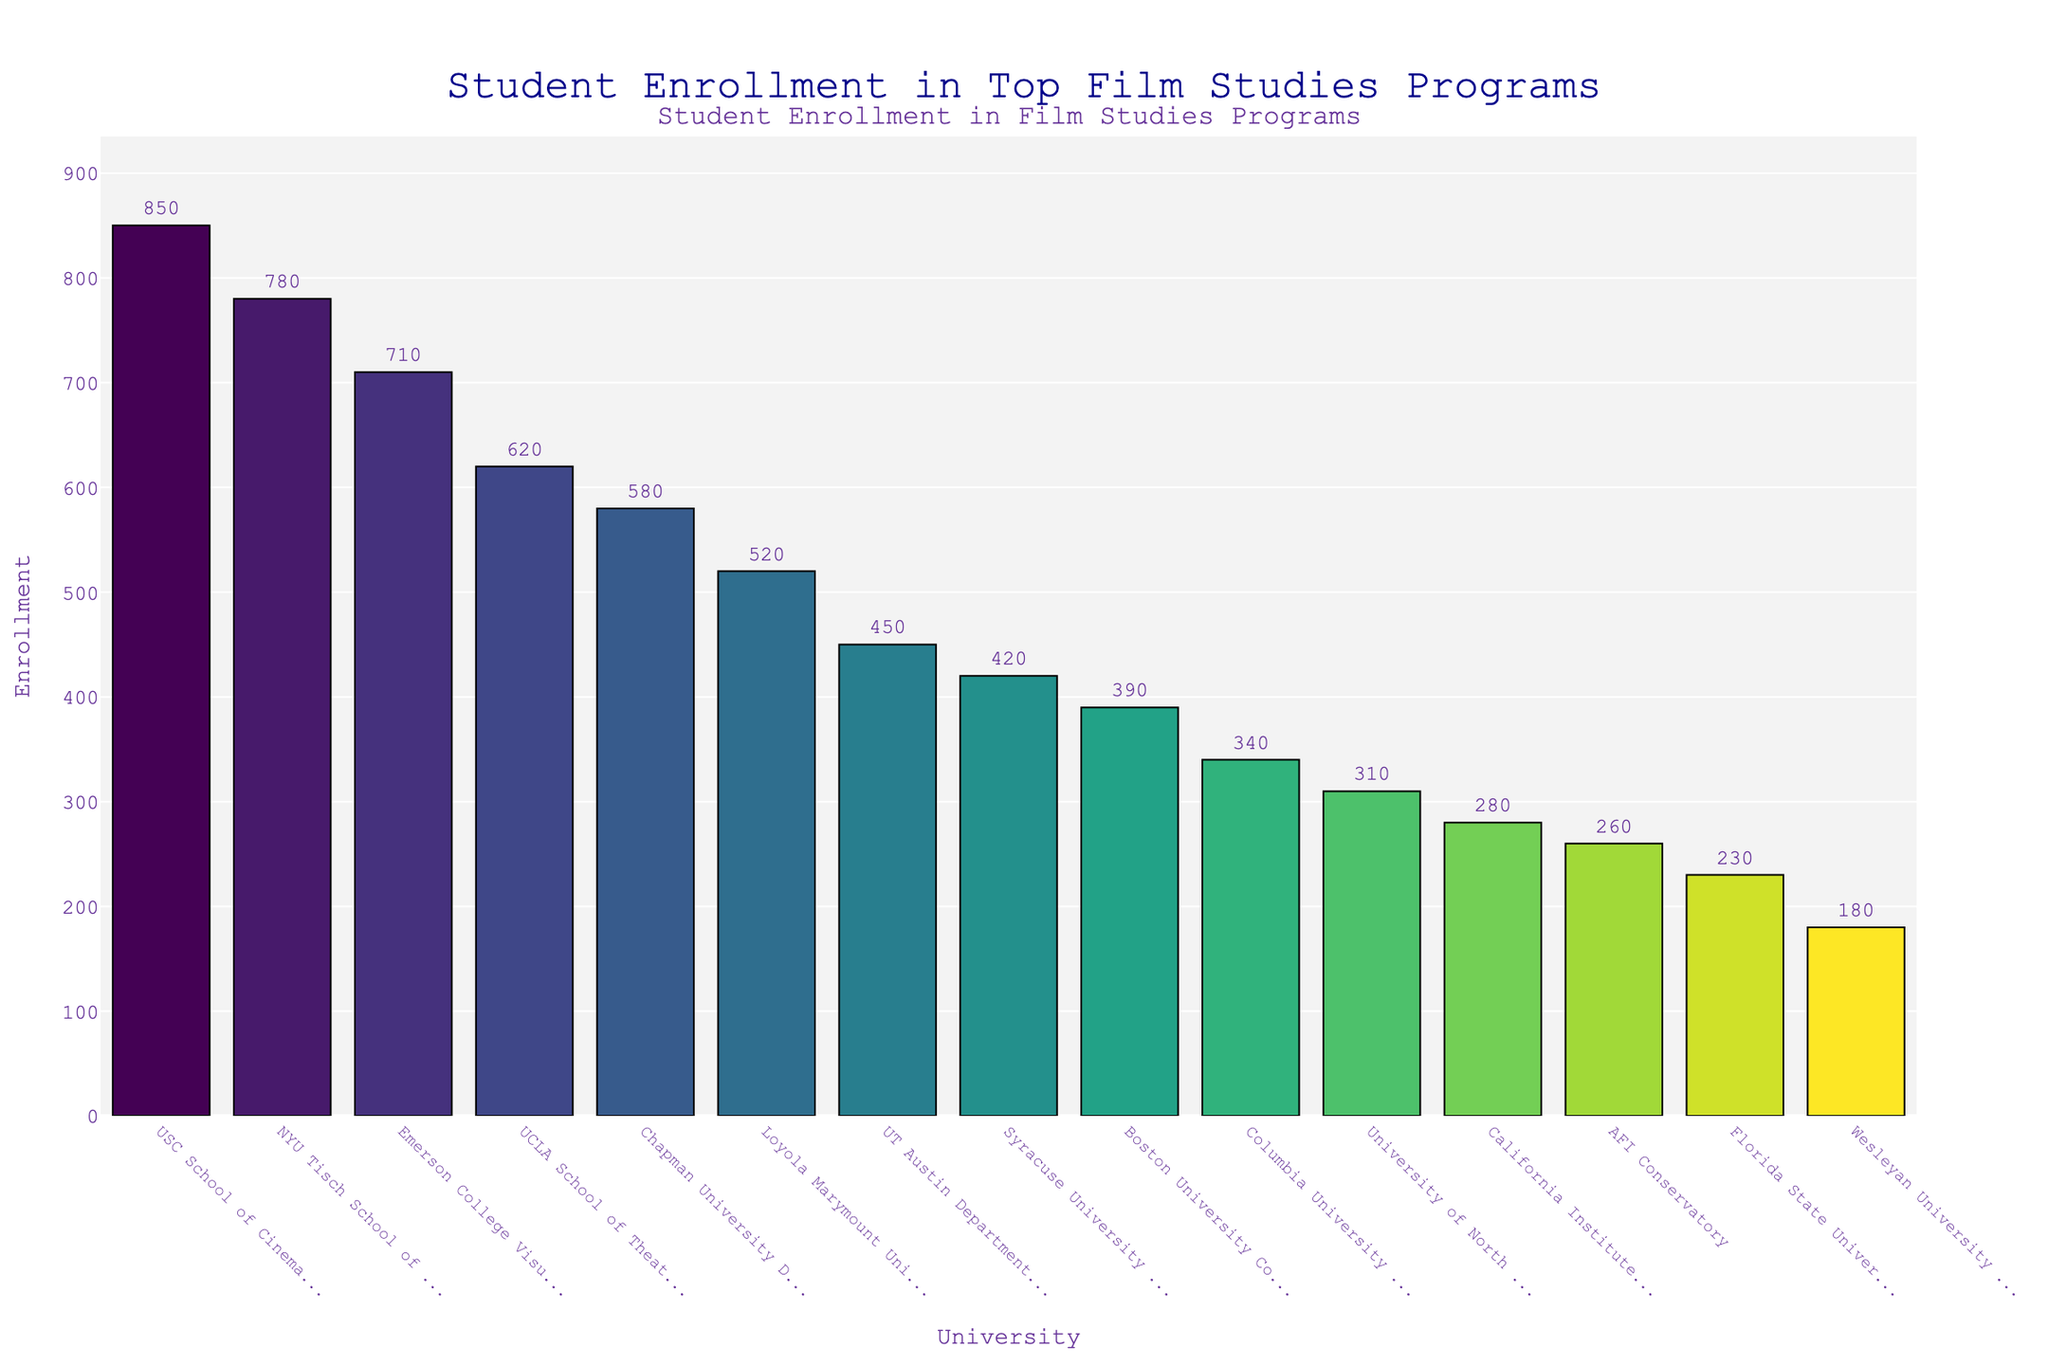what is the total enrollment of the top three universities combined? To find the total enrollment of the top three universities, look at the heights of the bars for "USC School of Cinematic Arts," "NYU Tisch School of the Arts," and "Emerson College Visual and Media Arts." Sum their enrollment numbers: 850 (USC) + 780 (NYU) + 710 (Emerson) = 2340.
Answer: 2340 Which university has the highest enrollment, and what is that enrollment? Identify the tallest bar on the chart; it corresponds to the university with the highest enrollment. The tallest bar is for "USC School of Cinematic Arts" with an enrollment of 850 students.
Answer: USC School of Cinematic Arts, 850 What is the difference in enrollment between Boston University College of Communication and California Institute of the Arts School of Film/Video? Find the heights of the bars for both universities. Boston University's enrollment is 390, and California Institute of the Arts' enrollment is 280. The difference is 390 - 280 = 110.
Answer: 110 How many universities have an enrollment greater than 500? Count the number of bars with heights corresponding to enrollments exceeding 500. The universities are "USC School of Cinematic Arts," "NYU Tisch School of the Arts," "Emerson College Visual and Media Arts," "Chapman University Dodge College," and "Loyola Marymount University School of Film and Television," totaling five.
Answer: 5 What is the average enrollment of universities with an enrollment of less than 300? First, identify universities with enrollments below 300. These are "AFI Conservatory" (260), "California Institute of the Arts School of Film/Video" (280), "Florida State University College of Motion Picture Arts" (230), and "Wesleyan University Film Studies" (180). Sum their enrollments: 260 + 280 + 230 + 180 = 950. Divide by the number of universities: 950 / 4 = 237.5.
Answer: 237.5 Which university has the second lowest enrollment, and what is that enrollment? Locate the two shortest bars. The shortest bar is for "Wesleyan University Film Studies" with 180, and the second shortest is "Florida State University College of Motion Picture Arts" with 230.
Answer: Florida State University College of Motion Picture Arts, 230 How does the enrollment of UCLA School of Theater Film and Television compare to Chapman University Dodge College? Compare the heights of the bars for both universities. UCLA's enrollment is 620, and Chapman's is 580. UCLA has a higher enrollment by 620 - 580 = 40.
Answer: UCLA has 40 more students than Chapman What are the two universities with the closest enrollments, and what is the difference? Look for bars with similar heights. "Boston University College of Communication" and "University of North Carolina School of the Arts" have close enrollments of 390 and 310, respectively. The difference is 390 - 310 = 80.
Answer: Boston University College of Communication, University of North Carolina School of the Arts, 80 